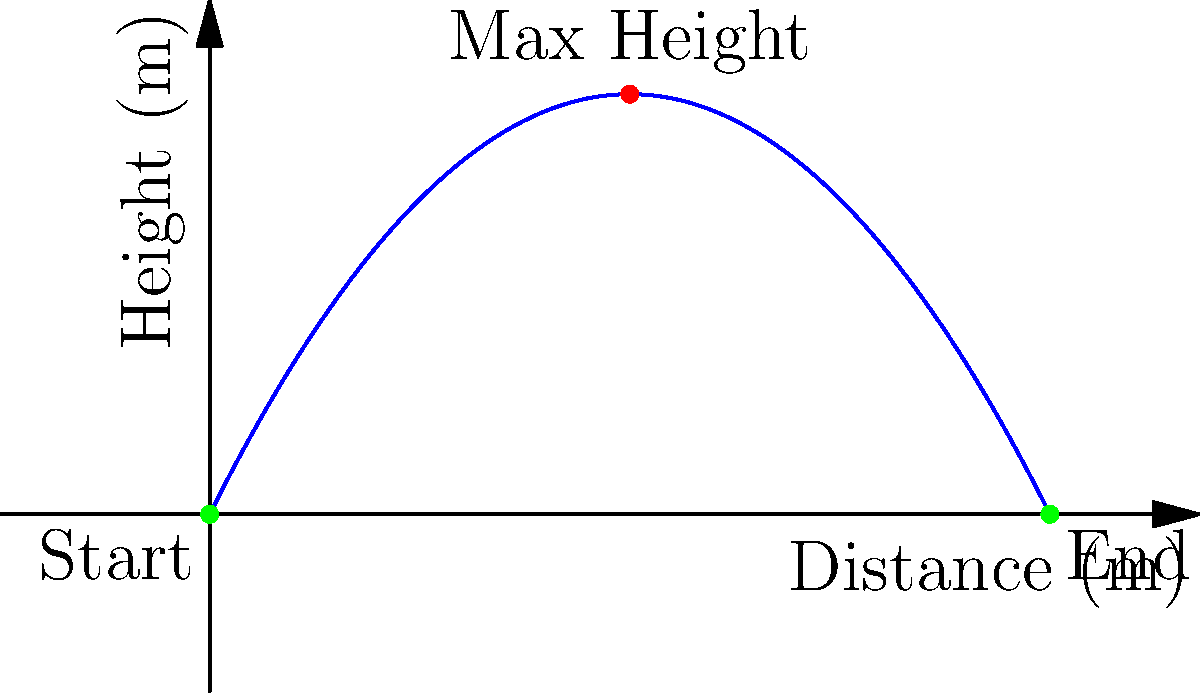On a television studio set, a prop ball is thrown with an initial velocity. The ball's trajectory follows the path shown in the graph, where the x-axis represents horizontal distance and the y-axis represents height. If the ball reaches a maximum height of 5 meters at a horizontal distance of 5 meters from the throwing point, what is the total horizontal distance traveled by the ball before it lands? Let's approach this step-by-step:

1) The trajectory of the ball follows a parabolic path, which is characteristic of projectile motion.

2) We're given that the maximum height is 5 meters, occurring at a horizontal distance of 5 meters. This means the parabola is symmetrical.

3) In a symmetrical parabola, the point of maximum height occurs exactly halfway through the horizontal trajectory.

4) Therefore, if the ball reaches its maximum height at 5 meters horizontally, it will travel an additional 5 meters before landing.

5) The total horizontal distance is thus:
   $$\text{Total Distance} = 5 \text{ m} + 5 \text{ m} = 10 \text{ m}$$

6) This matches with the graph, where we can see the ball starting at (0,0) and landing at (10,0).
Answer: 10 meters 